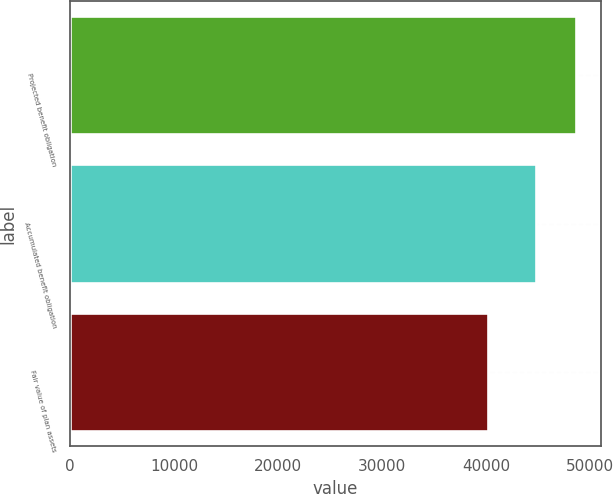Convert chart. <chart><loc_0><loc_0><loc_500><loc_500><bar_chart><fcel>Projected benefit obligation<fcel>Accumulated benefit obligation<fcel>Fair value of plan assets<nl><fcel>48658<fcel>44863<fcel>40225<nl></chart> 